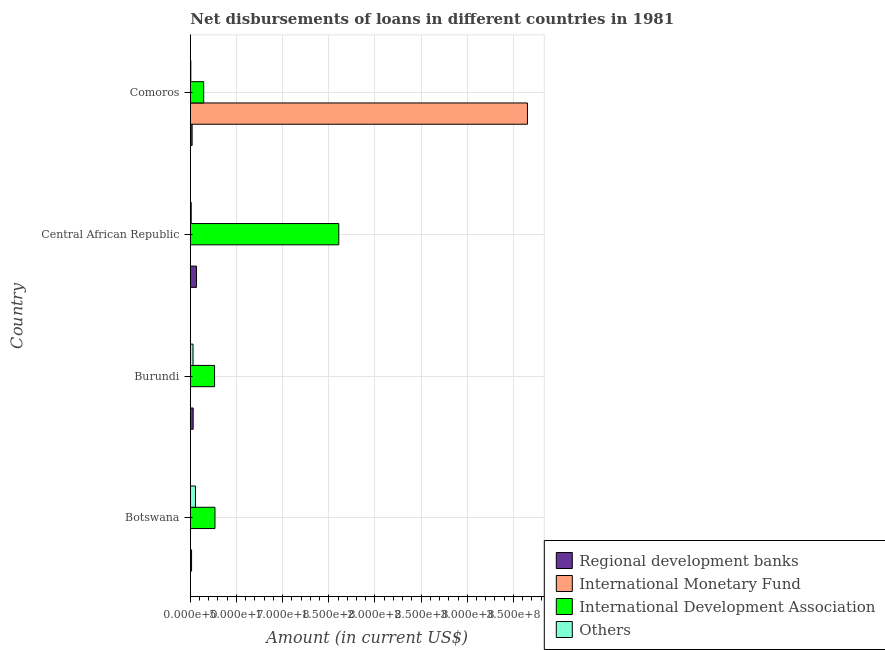How many different coloured bars are there?
Ensure brevity in your answer.  4. How many groups of bars are there?
Your answer should be very brief. 4. Are the number of bars on each tick of the Y-axis equal?
Provide a succinct answer. Yes. What is the label of the 2nd group of bars from the top?
Keep it short and to the point. Central African Republic. What is the amount of loan disimbursed by international development association in Comoros?
Your answer should be compact. 1.45e+07. Across all countries, what is the maximum amount of loan disimbursed by international monetary fund?
Offer a very short reply. 3.65e+08. Across all countries, what is the minimum amount of loan disimbursed by other organisations?
Provide a succinct answer. 5.81e+05. In which country was the amount of loan disimbursed by international development association maximum?
Offer a very short reply. Central African Republic. In which country was the amount of loan disimbursed by international development association minimum?
Your answer should be compact. Comoros. What is the total amount of loan disimbursed by international development association in the graph?
Provide a short and direct response. 2.28e+08. What is the difference between the amount of loan disimbursed by international development association in Botswana and that in Burundi?
Make the answer very short. 4.51e+05. What is the difference between the amount of loan disimbursed by regional development banks in Burundi and the amount of loan disimbursed by other organisations in Central African Republic?
Your answer should be compact. 2.09e+06. What is the average amount of loan disimbursed by international development association per country?
Provide a short and direct response. 5.71e+07. What is the difference between the amount of loan disimbursed by international monetary fund and amount of loan disimbursed by international development association in Botswana?
Provide a succinct answer. -2.66e+07. What is the ratio of the amount of loan disimbursed by international development association in Botswana to that in Comoros?
Give a very brief answer. 1.84. Is the amount of loan disimbursed by international development association in Botswana less than that in Burundi?
Make the answer very short. No. What is the difference between the highest and the second highest amount of loan disimbursed by international development association?
Keep it short and to the point. 1.34e+08. What is the difference between the highest and the lowest amount of loan disimbursed by international development association?
Your answer should be very brief. 1.46e+08. In how many countries, is the amount of loan disimbursed by international monetary fund greater than the average amount of loan disimbursed by international monetary fund taken over all countries?
Offer a terse response. 1. Is the sum of the amount of loan disimbursed by regional development banks in Burundi and Central African Republic greater than the maximum amount of loan disimbursed by other organisations across all countries?
Give a very brief answer. Yes. What does the 1st bar from the top in Burundi represents?
Offer a very short reply. Others. What does the 2nd bar from the bottom in Central African Republic represents?
Provide a short and direct response. International Monetary Fund. Does the graph contain any zero values?
Your answer should be compact. No. Where does the legend appear in the graph?
Give a very brief answer. Bottom right. How many legend labels are there?
Keep it short and to the point. 4. How are the legend labels stacked?
Your answer should be compact. Vertical. What is the title of the graph?
Your answer should be compact. Net disbursements of loans in different countries in 1981. What is the label or title of the X-axis?
Keep it short and to the point. Amount (in current US$). What is the Amount (in current US$) of Regional development banks in Botswana?
Offer a terse response. 1.37e+06. What is the Amount (in current US$) in International Monetary Fund in Botswana?
Your response must be concise. 1.65e+05. What is the Amount (in current US$) in International Development Association in Botswana?
Provide a short and direct response. 2.67e+07. What is the Amount (in current US$) in Others in Botswana?
Make the answer very short. 5.60e+06. What is the Amount (in current US$) of Regional development banks in Burundi?
Keep it short and to the point. 3.11e+06. What is the Amount (in current US$) in International Monetary Fund in Burundi?
Your answer should be compact. 5.80e+04. What is the Amount (in current US$) of International Development Association in Burundi?
Ensure brevity in your answer.  2.63e+07. What is the Amount (in current US$) of Others in Burundi?
Offer a very short reply. 2.94e+06. What is the Amount (in current US$) of Regional development banks in Central African Republic?
Provide a short and direct response. 6.69e+06. What is the Amount (in current US$) of International Monetary Fund in Central African Republic?
Make the answer very short. 1.56e+05. What is the Amount (in current US$) of International Development Association in Central African Republic?
Your answer should be compact. 1.61e+08. What is the Amount (in current US$) in Others in Central African Republic?
Your answer should be compact. 1.02e+06. What is the Amount (in current US$) of Regional development banks in Comoros?
Keep it short and to the point. 1.97e+06. What is the Amount (in current US$) of International Monetary Fund in Comoros?
Your answer should be very brief. 3.65e+08. What is the Amount (in current US$) in International Development Association in Comoros?
Give a very brief answer. 1.45e+07. What is the Amount (in current US$) in Others in Comoros?
Your answer should be compact. 5.81e+05. Across all countries, what is the maximum Amount (in current US$) of Regional development banks?
Your answer should be compact. 6.69e+06. Across all countries, what is the maximum Amount (in current US$) in International Monetary Fund?
Keep it short and to the point. 3.65e+08. Across all countries, what is the maximum Amount (in current US$) in International Development Association?
Keep it short and to the point. 1.61e+08. Across all countries, what is the maximum Amount (in current US$) of Others?
Your response must be concise. 5.60e+06. Across all countries, what is the minimum Amount (in current US$) in Regional development banks?
Keep it short and to the point. 1.37e+06. Across all countries, what is the minimum Amount (in current US$) of International Monetary Fund?
Provide a short and direct response. 5.80e+04. Across all countries, what is the minimum Amount (in current US$) of International Development Association?
Offer a terse response. 1.45e+07. Across all countries, what is the minimum Amount (in current US$) in Others?
Provide a short and direct response. 5.81e+05. What is the total Amount (in current US$) of Regional development banks in the graph?
Ensure brevity in your answer.  1.31e+07. What is the total Amount (in current US$) of International Monetary Fund in the graph?
Keep it short and to the point. 3.66e+08. What is the total Amount (in current US$) of International Development Association in the graph?
Ensure brevity in your answer.  2.28e+08. What is the total Amount (in current US$) of Others in the graph?
Your answer should be very brief. 1.02e+07. What is the difference between the Amount (in current US$) of Regional development banks in Botswana and that in Burundi?
Offer a terse response. -1.74e+06. What is the difference between the Amount (in current US$) of International Monetary Fund in Botswana and that in Burundi?
Keep it short and to the point. 1.07e+05. What is the difference between the Amount (in current US$) in International Development Association in Botswana and that in Burundi?
Provide a short and direct response. 4.51e+05. What is the difference between the Amount (in current US$) of Others in Botswana and that in Burundi?
Ensure brevity in your answer.  2.66e+06. What is the difference between the Amount (in current US$) of Regional development banks in Botswana and that in Central African Republic?
Ensure brevity in your answer.  -5.32e+06. What is the difference between the Amount (in current US$) of International Monetary Fund in Botswana and that in Central African Republic?
Provide a short and direct response. 9000. What is the difference between the Amount (in current US$) of International Development Association in Botswana and that in Central African Republic?
Ensure brevity in your answer.  -1.34e+08. What is the difference between the Amount (in current US$) of Others in Botswana and that in Central African Republic?
Your response must be concise. 4.59e+06. What is the difference between the Amount (in current US$) of Regional development banks in Botswana and that in Comoros?
Provide a short and direct response. -6.01e+05. What is the difference between the Amount (in current US$) of International Monetary Fund in Botswana and that in Comoros?
Keep it short and to the point. -3.65e+08. What is the difference between the Amount (in current US$) in International Development Association in Botswana and that in Comoros?
Your answer should be compact. 1.22e+07. What is the difference between the Amount (in current US$) in Others in Botswana and that in Comoros?
Your answer should be compact. 5.02e+06. What is the difference between the Amount (in current US$) in Regional development banks in Burundi and that in Central African Republic?
Ensure brevity in your answer.  -3.58e+06. What is the difference between the Amount (in current US$) in International Monetary Fund in Burundi and that in Central African Republic?
Ensure brevity in your answer.  -9.80e+04. What is the difference between the Amount (in current US$) in International Development Association in Burundi and that in Central African Republic?
Keep it short and to the point. -1.35e+08. What is the difference between the Amount (in current US$) in Others in Burundi and that in Central African Republic?
Ensure brevity in your answer.  1.93e+06. What is the difference between the Amount (in current US$) in Regional development banks in Burundi and that in Comoros?
Ensure brevity in your answer.  1.14e+06. What is the difference between the Amount (in current US$) in International Monetary Fund in Burundi and that in Comoros?
Make the answer very short. -3.65e+08. What is the difference between the Amount (in current US$) of International Development Association in Burundi and that in Comoros?
Make the answer very short. 1.18e+07. What is the difference between the Amount (in current US$) in Others in Burundi and that in Comoros?
Your response must be concise. 2.36e+06. What is the difference between the Amount (in current US$) in Regional development banks in Central African Republic and that in Comoros?
Ensure brevity in your answer.  4.72e+06. What is the difference between the Amount (in current US$) of International Monetary Fund in Central African Republic and that in Comoros?
Your answer should be very brief. -3.65e+08. What is the difference between the Amount (in current US$) of International Development Association in Central African Republic and that in Comoros?
Your answer should be compact. 1.46e+08. What is the difference between the Amount (in current US$) of Others in Central African Republic and that in Comoros?
Give a very brief answer. 4.38e+05. What is the difference between the Amount (in current US$) of Regional development banks in Botswana and the Amount (in current US$) of International Monetary Fund in Burundi?
Keep it short and to the point. 1.31e+06. What is the difference between the Amount (in current US$) in Regional development banks in Botswana and the Amount (in current US$) in International Development Association in Burundi?
Ensure brevity in your answer.  -2.49e+07. What is the difference between the Amount (in current US$) of Regional development banks in Botswana and the Amount (in current US$) of Others in Burundi?
Make the answer very short. -1.57e+06. What is the difference between the Amount (in current US$) of International Monetary Fund in Botswana and the Amount (in current US$) of International Development Association in Burundi?
Keep it short and to the point. -2.61e+07. What is the difference between the Amount (in current US$) of International Monetary Fund in Botswana and the Amount (in current US$) of Others in Burundi?
Offer a very short reply. -2.78e+06. What is the difference between the Amount (in current US$) of International Development Association in Botswana and the Amount (in current US$) of Others in Burundi?
Offer a very short reply. 2.38e+07. What is the difference between the Amount (in current US$) in Regional development banks in Botswana and the Amount (in current US$) in International Monetary Fund in Central African Republic?
Your answer should be very brief. 1.22e+06. What is the difference between the Amount (in current US$) in Regional development banks in Botswana and the Amount (in current US$) in International Development Association in Central African Republic?
Ensure brevity in your answer.  -1.59e+08. What is the difference between the Amount (in current US$) in Regional development banks in Botswana and the Amount (in current US$) in Others in Central African Republic?
Keep it short and to the point. 3.52e+05. What is the difference between the Amount (in current US$) of International Monetary Fund in Botswana and the Amount (in current US$) of International Development Association in Central African Republic?
Ensure brevity in your answer.  -1.61e+08. What is the difference between the Amount (in current US$) in International Monetary Fund in Botswana and the Amount (in current US$) in Others in Central African Republic?
Make the answer very short. -8.54e+05. What is the difference between the Amount (in current US$) in International Development Association in Botswana and the Amount (in current US$) in Others in Central African Republic?
Your answer should be compact. 2.57e+07. What is the difference between the Amount (in current US$) of Regional development banks in Botswana and the Amount (in current US$) of International Monetary Fund in Comoros?
Make the answer very short. -3.64e+08. What is the difference between the Amount (in current US$) of Regional development banks in Botswana and the Amount (in current US$) of International Development Association in Comoros?
Your answer should be very brief. -1.31e+07. What is the difference between the Amount (in current US$) in Regional development banks in Botswana and the Amount (in current US$) in Others in Comoros?
Provide a short and direct response. 7.90e+05. What is the difference between the Amount (in current US$) in International Monetary Fund in Botswana and the Amount (in current US$) in International Development Association in Comoros?
Provide a succinct answer. -1.44e+07. What is the difference between the Amount (in current US$) in International Monetary Fund in Botswana and the Amount (in current US$) in Others in Comoros?
Give a very brief answer. -4.16e+05. What is the difference between the Amount (in current US$) of International Development Association in Botswana and the Amount (in current US$) of Others in Comoros?
Give a very brief answer. 2.62e+07. What is the difference between the Amount (in current US$) in Regional development banks in Burundi and the Amount (in current US$) in International Monetary Fund in Central African Republic?
Your response must be concise. 2.96e+06. What is the difference between the Amount (in current US$) of Regional development banks in Burundi and the Amount (in current US$) of International Development Association in Central African Republic?
Your response must be concise. -1.58e+08. What is the difference between the Amount (in current US$) of Regional development banks in Burundi and the Amount (in current US$) of Others in Central African Republic?
Offer a very short reply. 2.09e+06. What is the difference between the Amount (in current US$) of International Monetary Fund in Burundi and the Amount (in current US$) of International Development Association in Central African Republic?
Ensure brevity in your answer.  -1.61e+08. What is the difference between the Amount (in current US$) of International Monetary Fund in Burundi and the Amount (in current US$) of Others in Central African Republic?
Keep it short and to the point. -9.61e+05. What is the difference between the Amount (in current US$) in International Development Association in Burundi and the Amount (in current US$) in Others in Central African Republic?
Provide a succinct answer. 2.53e+07. What is the difference between the Amount (in current US$) of Regional development banks in Burundi and the Amount (in current US$) of International Monetary Fund in Comoros?
Offer a terse response. -3.62e+08. What is the difference between the Amount (in current US$) in Regional development banks in Burundi and the Amount (in current US$) in International Development Association in Comoros?
Your answer should be compact. -1.14e+07. What is the difference between the Amount (in current US$) of Regional development banks in Burundi and the Amount (in current US$) of Others in Comoros?
Offer a terse response. 2.53e+06. What is the difference between the Amount (in current US$) of International Monetary Fund in Burundi and the Amount (in current US$) of International Development Association in Comoros?
Your answer should be compact. -1.45e+07. What is the difference between the Amount (in current US$) of International Monetary Fund in Burundi and the Amount (in current US$) of Others in Comoros?
Ensure brevity in your answer.  -5.23e+05. What is the difference between the Amount (in current US$) in International Development Association in Burundi and the Amount (in current US$) in Others in Comoros?
Offer a terse response. 2.57e+07. What is the difference between the Amount (in current US$) of Regional development banks in Central African Republic and the Amount (in current US$) of International Monetary Fund in Comoros?
Ensure brevity in your answer.  -3.58e+08. What is the difference between the Amount (in current US$) in Regional development banks in Central African Republic and the Amount (in current US$) in International Development Association in Comoros?
Your answer should be very brief. -7.83e+06. What is the difference between the Amount (in current US$) in Regional development banks in Central African Republic and the Amount (in current US$) in Others in Comoros?
Provide a short and direct response. 6.11e+06. What is the difference between the Amount (in current US$) of International Monetary Fund in Central African Republic and the Amount (in current US$) of International Development Association in Comoros?
Provide a short and direct response. -1.44e+07. What is the difference between the Amount (in current US$) of International Monetary Fund in Central African Republic and the Amount (in current US$) of Others in Comoros?
Your response must be concise. -4.25e+05. What is the difference between the Amount (in current US$) of International Development Association in Central African Republic and the Amount (in current US$) of Others in Comoros?
Offer a very short reply. 1.60e+08. What is the average Amount (in current US$) of Regional development banks per country?
Provide a short and direct response. 3.29e+06. What is the average Amount (in current US$) of International Monetary Fund per country?
Offer a very short reply. 9.14e+07. What is the average Amount (in current US$) in International Development Association per country?
Offer a terse response. 5.71e+07. What is the average Amount (in current US$) of Others per country?
Your answer should be compact. 2.54e+06. What is the difference between the Amount (in current US$) in Regional development banks and Amount (in current US$) in International Monetary Fund in Botswana?
Provide a short and direct response. 1.21e+06. What is the difference between the Amount (in current US$) in Regional development banks and Amount (in current US$) in International Development Association in Botswana?
Provide a short and direct response. -2.54e+07. What is the difference between the Amount (in current US$) of Regional development banks and Amount (in current US$) of Others in Botswana?
Ensure brevity in your answer.  -4.23e+06. What is the difference between the Amount (in current US$) of International Monetary Fund and Amount (in current US$) of International Development Association in Botswana?
Offer a terse response. -2.66e+07. What is the difference between the Amount (in current US$) in International Monetary Fund and Amount (in current US$) in Others in Botswana?
Your response must be concise. -5.44e+06. What is the difference between the Amount (in current US$) in International Development Association and Amount (in current US$) in Others in Botswana?
Offer a very short reply. 2.11e+07. What is the difference between the Amount (in current US$) of Regional development banks and Amount (in current US$) of International Monetary Fund in Burundi?
Offer a terse response. 3.06e+06. What is the difference between the Amount (in current US$) of Regional development banks and Amount (in current US$) of International Development Association in Burundi?
Offer a very short reply. -2.32e+07. What is the difference between the Amount (in current US$) in Regional development banks and Amount (in current US$) in Others in Burundi?
Make the answer very short. 1.68e+05. What is the difference between the Amount (in current US$) in International Monetary Fund and Amount (in current US$) in International Development Association in Burundi?
Your answer should be very brief. -2.62e+07. What is the difference between the Amount (in current US$) in International Monetary Fund and Amount (in current US$) in Others in Burundi?
Your answer should be very brief. -2.89e+06. What is the difference between the Amount (in current US$) in International Development Association and Amount (in current US$) in Others in Burundi?
Your answer should be very brief. 2.33e+07. What is the difference between the Amount (in current US$) of Regional development banks and Amount (in current US$) of International Monetary Fund in Central African Republic?
Offer a very short reply. 6.54e+06. What is the difference between the Amount (in current US$) of Regional development banks and Amount (in current US$) of International Development Association in Central African Republic?
Your response must be concise. -1.54e+08. What is the difference between the Amount (in current US$) in Regional development banks and Amount (in current US$) in Others in Central African Republic?
Make the answer very short. 5.67e+06. What is the difference between the Amount (in current US$) of International Monetary Fund and Amount (in current US$) of International Development Association in Central African Republic?
Give a very brief answer. -1.61e+08. What is the difference between the Amount (in current US$) of International Monetary Fund and Amount (in current US$) of Others in Central African Republic?
Provide a succinct answer. -8.63e+05. What is the difference between the Amount (in current US$) in International Development Association and Amount (in current US$) in Others in Central African Republic?
Provide a short and direct response. 1.60e+08. What is the difference between the Amount (in current US$) of Regional development banks and Amount (in current US$) of International Monetary Fund in Comoros?
Ensure brevity in your answer.  -3.63e+08. What is the difference between the Amount (in current US$) in Regional development banks and Amount (in current US$) in International Development Association in Comoros?
Give a very brief answer. -1.25e+07. What is the difference between the Amount (in current US$) of Regional development banks and Amount (in current US$) of Others in Comoros?
Keep it short and to the point. 1.39e+06. What is the difference between the Amount (in current US$) of International Monetary Fund and Amount (in current US$) of International Development Association in Comoros?
Provide a short and direct response. 3.51e+08. What is the difference between the Amount (in current US$) in International Monetary Fund and Amount (in current US$) in Others in Comoros?
Ensure brevity in your answer.  3.65e+08. What is the difference between the Amount (in current US$) in International Development Association and Amount (in current US$) in Others in Comoros?
Your response must be concise. 1.39e+07. What is the ratio of the Amount (in current US$) in Regional development banks in Botswana to that in Burundi?
Your response must be concise. 0.44. What is the ratio of the Amount (in current US$) of International Monetary Fund in Botswana to that in Burundi?
Provide a short and direct response. 2.84. What is the ratio of the Amount (in current US$) of International Development Association in Botswana to that in Burundi?
Your answer should be very brief. 1.02. What is the ratio of the Amount (in current US$) in Others in Botswana to that in Burundi?
Your answer should be very brief. 1.9. What is the ratio of the Amount (in current US$) in Regional development banks in Botswana to that in Central African Republic?
Offer a terse response. 0.2. What is the ratio of the Amount (in current US$) of International Monetary Fund in Botswana to that in Central African Republic?
Offer a very short reply. 1.06. What is the ratio of the Amount (in current US$) of International Development Association in Botswana to that in Central African Republic?
Keep it short and to the point. 0.17. What is the ratio of the Amount (in current US$) of Others in Botswana to that in Central African Republic?
Your response must be concise. 5.5. What is the ratio of the Amount (in current US$) of Regional development banks in Botswana to that in Comoros?
Keep it short and to the point. 0.7. What is the ratio of the Amount (in current US$) in International Development Association in Botswana to that in Comoros?
Provide a succinct answer. 1.84. What is the ratio of the Amount (in current US$) in Others in Botswana to that in Comoros?
Make the answer very short. 9.65. What is the ratio of the Amount (in current US$) of Regional development banks in Burundi to that in Central African Republic?
Your response must be concise. 0.47. What is the ratio of the Amount (in current US$) in International Monetary Fund in Burundi to that in Central African Republic?
Make the answer very short. 0.37. What is the ratio of the Amount (in current US$) of International Development Association in Burundi to that in Central African Republic?
Keep it short and to the point. 0.16. What is the ratio of the Amount (in current US$) in Others in Burundi to that in Central African Republic?
Your response must be concise. 2.89. What is the ratio of the Amount (in current US$) in Regional development banks in Burundi to that in Comoros?
Offer a very short reply. 1.58. What is the ratio of the Amount (in current US$) in International Monetary Fund in Burundi to that in Comoros?
Ensure brevity in your answer.  0. What is the ratio of the Amount (in current US$) of International Development Association in Burundi to that in Comoros?
Offer a very short reply. 1.81. What is the ratio of the Amount (in current US$) of Others in Burundi to that in Comoros?
Your answer should be very brief. 5.07. What is the ratio of the Amount (in current US$) of Regional development banks in Central African Republic to that in Comoros?
Provide a short and direct response. 3.39. What is the ratio of the Amount (in current US$) in International Development Association in Central African Republic to that in Comoros?
Your response must be concise. 11.08. What is the ratio of the Amount (in current US$) in Others in Central African Republic to that in Comoros?
Your answer should be very brief. 1.75. What is the difference between the highest and the second highest Amount (in current US$) in Regional development banks?
Keep it short and to the point. 3.58e+06. What is the difference between the highest and the second highest Amount (in current US$) in International Monetary Fund?
Offer a terse response. 3.65e+08. What is the difference between the highest and the second highest Amount (in current US$) of International Development Association?
Offer a terse response. 1.34e+08. What is the difference between the highest and the second highest Amount (in current US$) in Others?
Keep it short and to the point. 2.66e+06. What is the difference between the highest and the lowest Amount (in current US$) of Regional development banks?
Ensure brevity in your answer.  5.32e+06. What is the difference between the highest and the lowest Amount (in current US$) of International Monetary Fund?
Give a very brief answer. 3.65e+08. What is the difference between the highest and the lowest Amount (in current US$) in International Development Association?
Your answer should be very brief. 1.46e+08. What is the difference between the highest and the lowest Amount (in current US$) of Others?
Provide a short and direct response. 5.02e+06. 